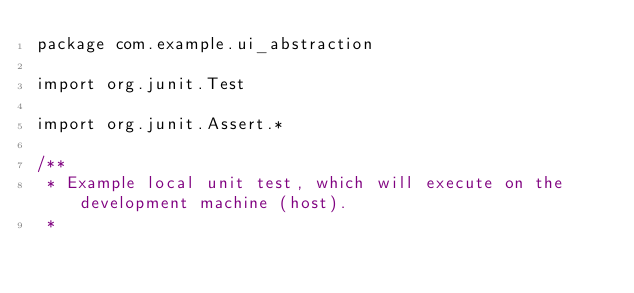Convert code to text. <code><loc_0><loc_0><loc_500><loc_500><_Kotlin_>package com.example.ui_abstraction

import org.junit.Test

import org.junit.Assert.*

/**
 * Example local unit test, which will execute on the development machine (host).
 *</code> 